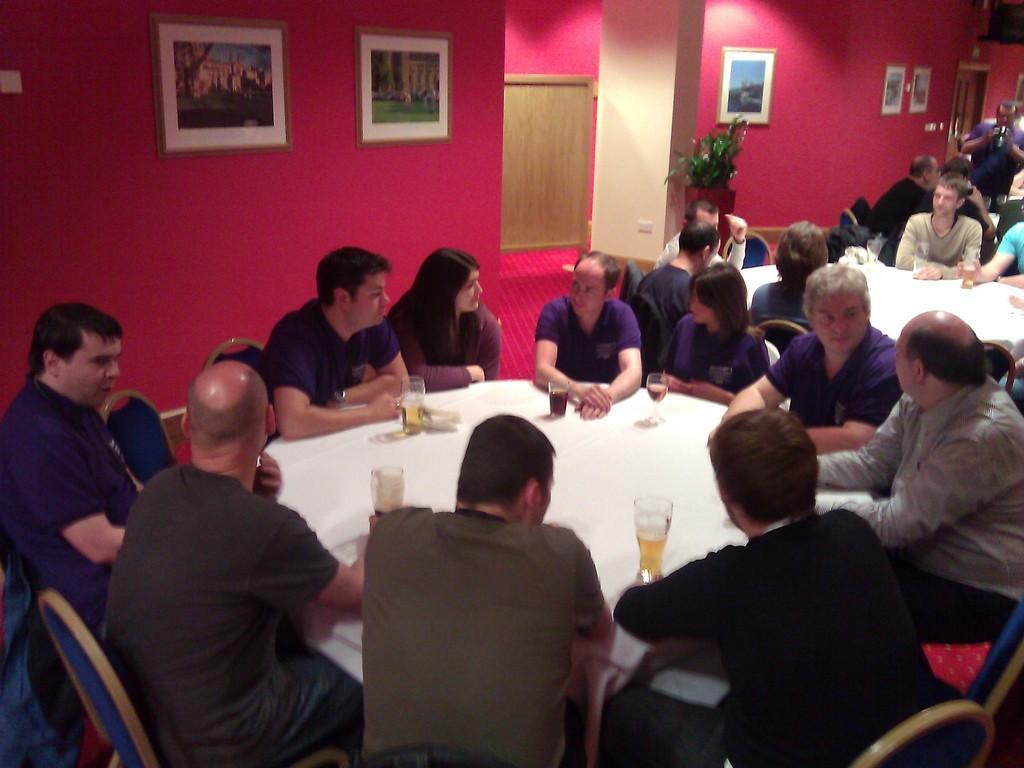In one or two sentences, can you explain what this image depicts? As we can see in the image, there are few people sitting on chairs around table. On table there are glasses and on wall there are few frames. 